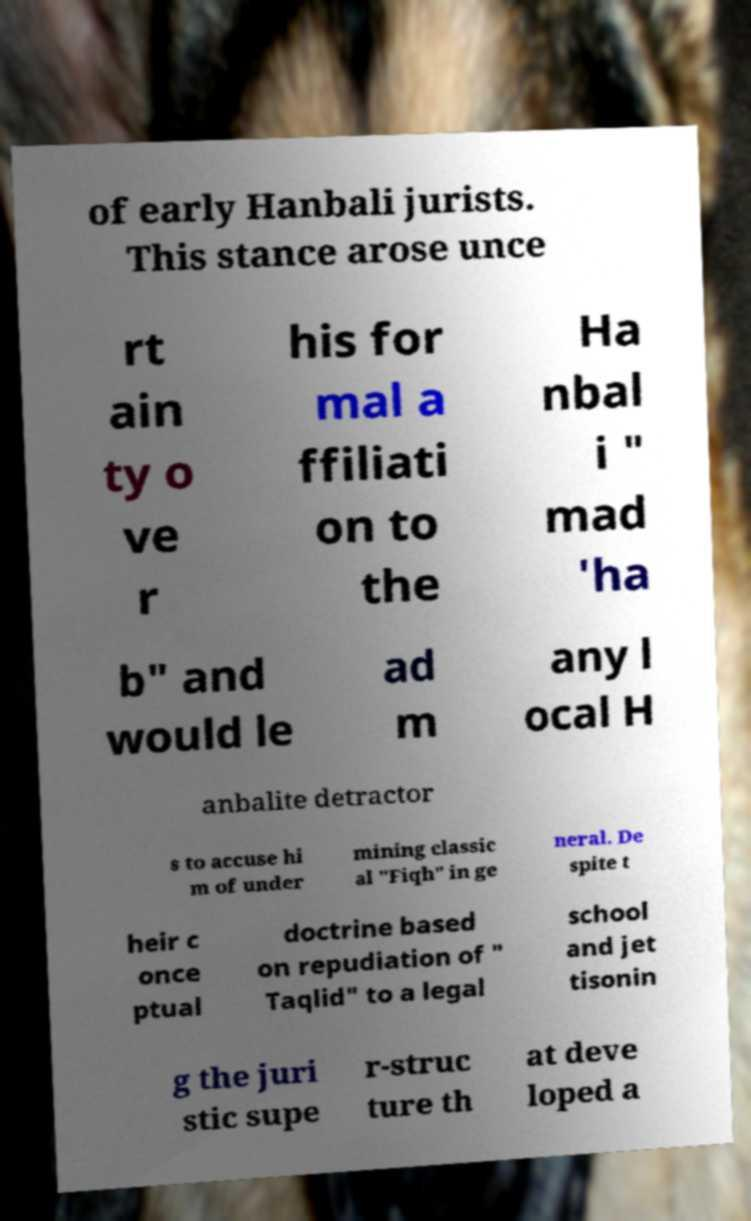Please identify and transcribe the text found in this image. of early Hanbali jurists. This stance arose unce rt ain ty o ve r his for mal a ffiliati on to the Ha nbal i " mad 'ha b" and would le ad m any l ocal H anbalite detractor s to accuse hi m of under mining classic al "Fiqh" in ge neral. De spite t heir c once ptual doctrine based on repudiation of " Taqlid" to a legal school and jet tisonin g the juri stic supe r-struc ture th at deve loped a 